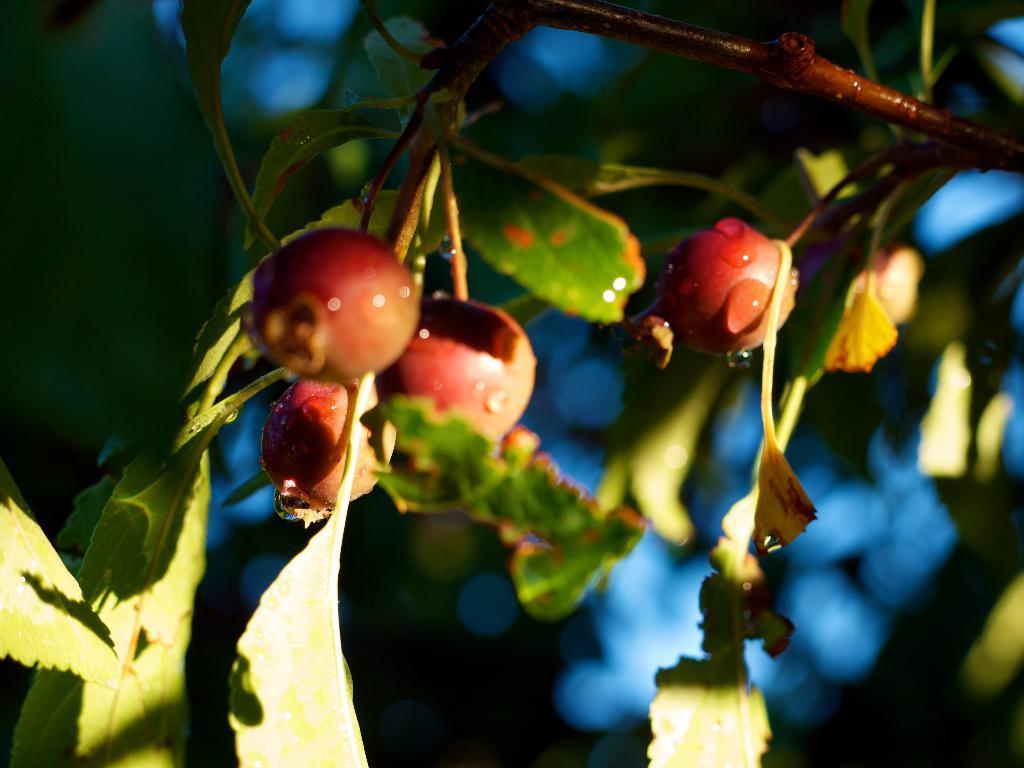Can you describe this image briefly? In this image we can see fruits, leaves and stems. Background it is blur. 